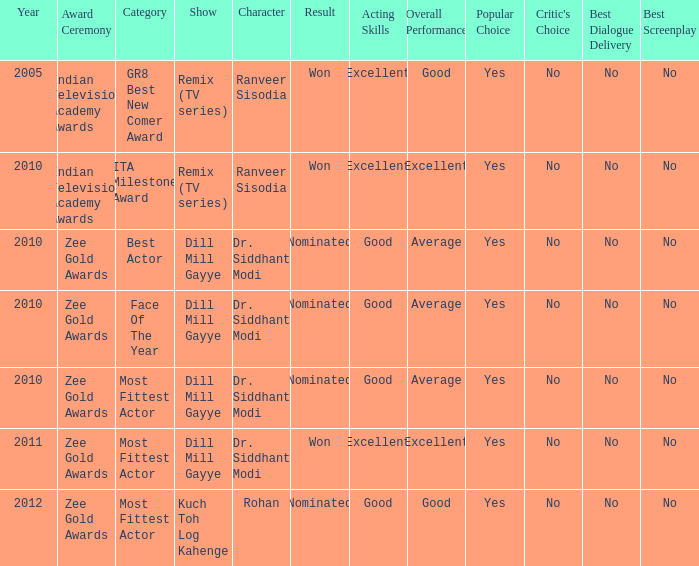Which show was nominated for the ITA Milestone Award at the Indian Television Academy Awards? Remix (TV series). 